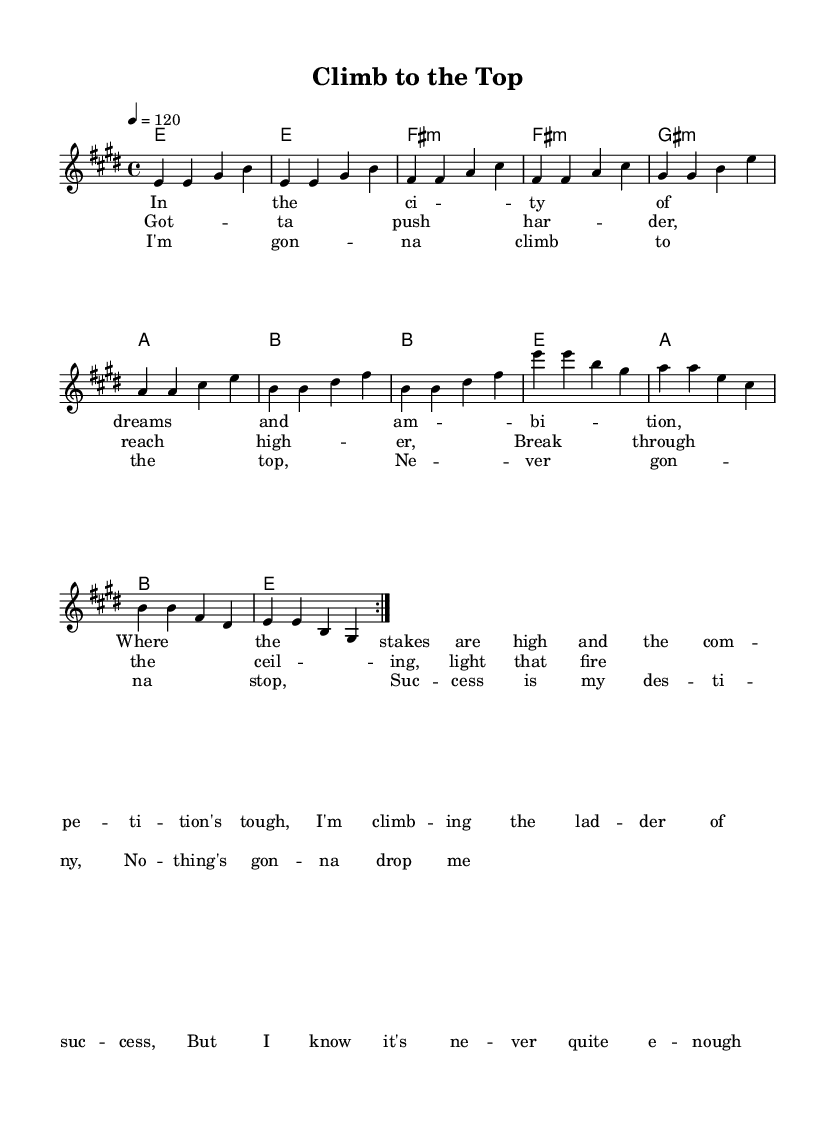What is the key signature of this music? The key signature is based on the "e major" key, which contains four sharps: F#, C#, G#, and D#. This can be identified at the beginning of the staff where the key signature is displayed.
Answer: E major What is the time signature of this piece? The time signature shown in the music sheet is "4/4," which means there are four beats in each measure, and the quarter note gets one beat. This is typically indicated at the start of the score.
Answer: 4/4 What is the tempo marking for this music? The tempo marking is defined as "4 = 120," indicating a moderate tempo where the quarter note is played at a speed of 120 beats per minute. This is specified right below the title.
Answer: 120 How many repeats are indicated in the melody section? The melody section indicates a repeat structure with the instruction "repeat volta 2," meaning the melody should be played twice before proceeding. This note is an essential part of the melody line.
Answer: 2 What is the first lyric line in the verse? The first lyric line of the verse reads "In the ci -- ty of dreams and am -- bi -- tion." The lyrics are provided under the melody line, aligning with the corresponding notes.
Answer: In the city of dreams and ambition Which chord is played after the second "e" note in the melody? The chord played after the second "e" note in the melody is "fis:m," represented in the chord section. This follows the melodic note progression given on the staff.
Answer: F# minor 